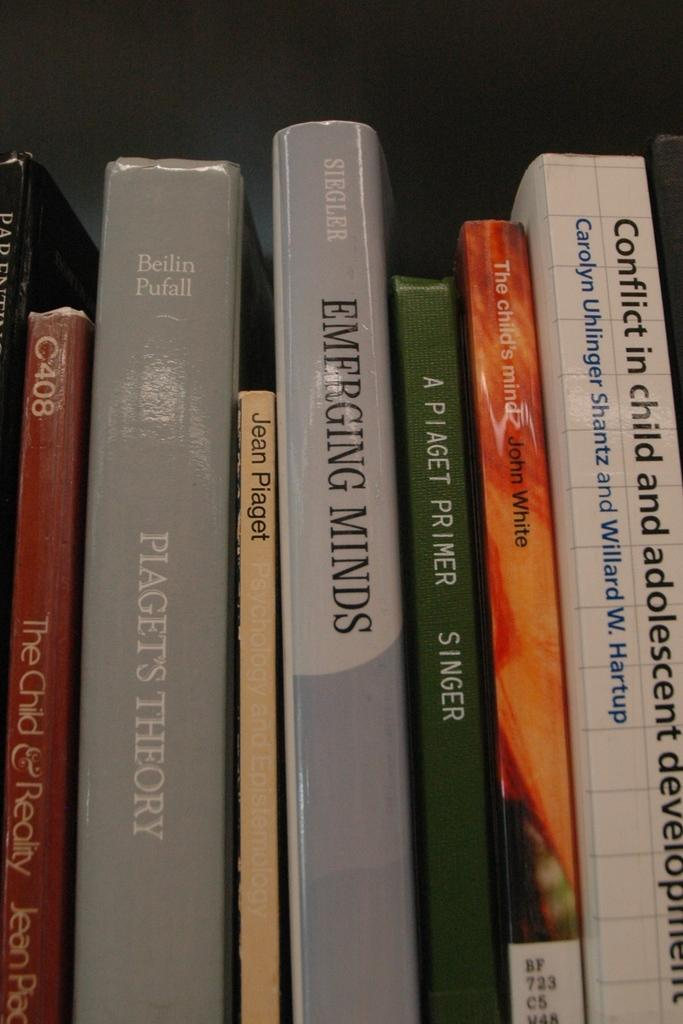<image>
Relay a brief, clear account of the picture shown. A book titled Emerging Minds sits on a shelf next to a book by Jean Plaget 